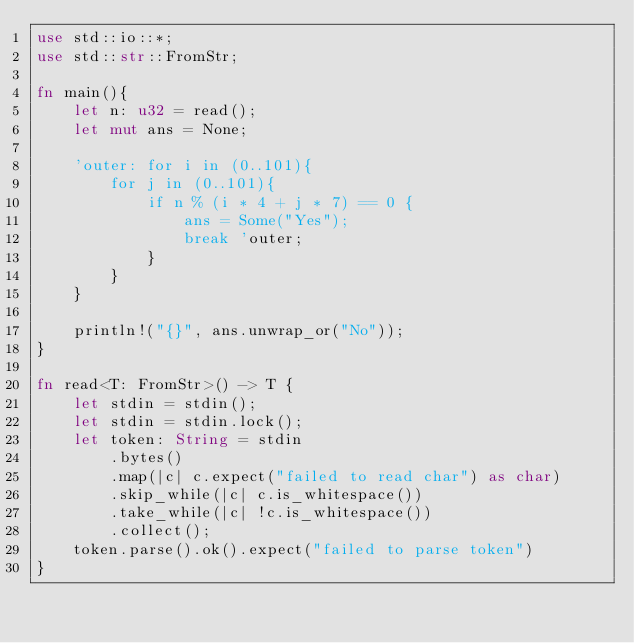Convert code to text. <code><loc_0><loc_0><loc_500><loc_500><_Rust_>use std::io::*;
use std::str::FromStr;

fn main(){
    let n: u32 = read();
    let mut ans = None;

    'outer: for i in (0..101){
        for j in (0..101){
            if n % (i * 4 + j * 7) == 0 {
                ans = Some("Yes");
                break 'outer;
            }
        }
    }

    println!("{}", ans.unwrap_or("No"));
} 

fn read<T: FromStr>() -> T {
    let stdin = stdin();
    let stdin = stdin.lock();
    let token: String = stdin
        .bytes()
        .map(|c| c.expect("failed to read char") as char) 
        .skip_while(|c| c.is_whitespace())
        .take_while(|c| !c.is_whitespace())
        .collect();
    token.parse().ok().expect("failed to parse token")
}</code> 